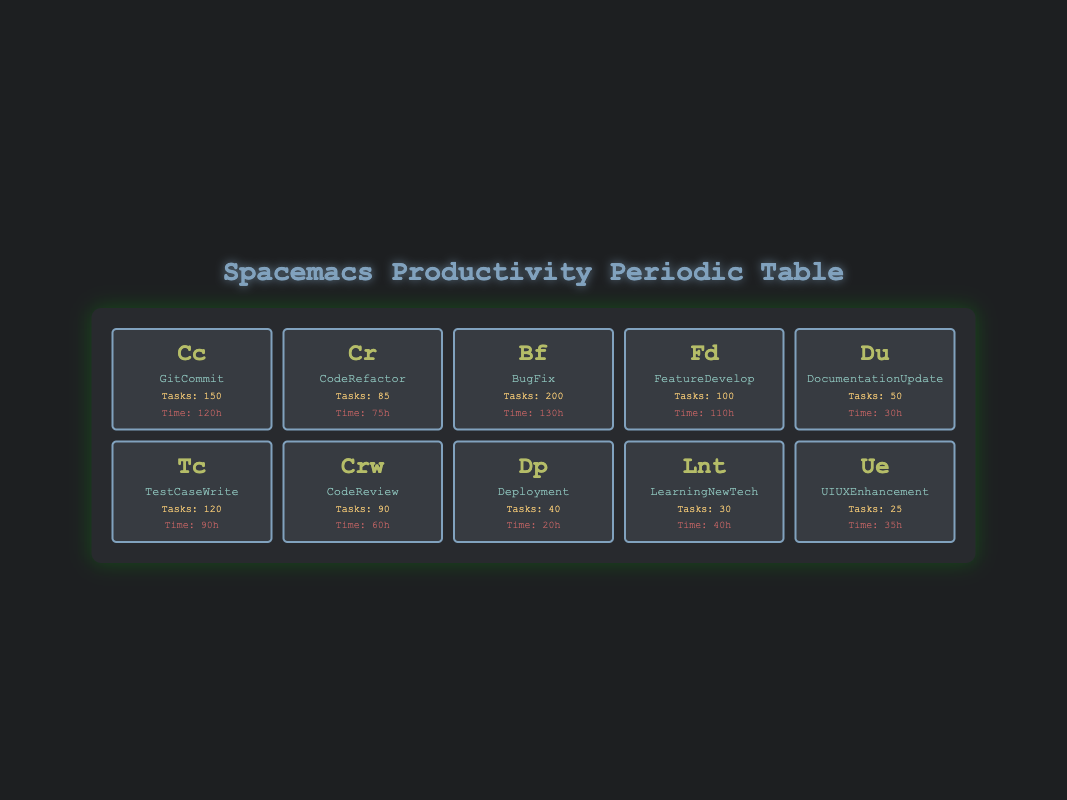What is the total number of tasks completed across all categories? To find the total number of tasks, we add the tasks completed for all categories: 150 (GitCommit) + 85 (CodeRefactor) + 200 (BugFix) + 100 (FeatureDevelop) + 50 (DocumentationUpdate) + 120 (TestCaseWrite) + 90 (CodeReview) + 40 (Deployment) + 30 (LearningNewTech) + 25 (UIUXEnhancement) = 1,050.
Answer: 1050 Which category has the highest time spent? The time spent for each category is: 120 (GitCommit), 75 (CodeRefactor), 130 (BugFix), 110 (FeatureDevelop), 30 (DocumentationUpdate), 90 (TestCaseWrite), 60 (CodeReview), 20 (Deployment), 40 (LearningNewTech), and 35 (UIUXEnhancement). The maximum time spent is 130 in the BugFix category.
Answer: BugFix Is the number of tasks completed for Deployment greater than the number of tasks for LearningNewTech? The tasks completed for Deployment is 40, and for LearningNewTech it is 30. Since 40 is greater than 30, the statement is true.
Answer: Yes What is the average time spent on tasks for the top 3 categories by tasks completed? The top 3 categories by tasks completed are: BugFix (200), GitCommit (150), and TestCaseWrite (120). Their corresponding time spent is 130 (BugFix), 120 (GitCommit), and 90 (TestCaseWrite). The average time is calculated as (130 + 120 + 90) / 3 = 340 / 3 = approximately 113.33 hours.
Answer: 113.33 How many more tasks were completed in BugFix compared to DocumentationUpdate? The tasks completed in BugFix is 200 and in DocumentationUpdate is 50. The difference is 200 - 50 = 150 tasks.
Answer: 150 Which element has the least number of tasks completed? The tasks completed for elements are: 150 (GitCommit), 85 (CodeRefactor), 200 (BugFix), 100 (FeatureDevelop), 50 (DocumentationUpdate), 120 (TestCaseWrite), 90 (CodeReview), 40 (Deployment), 30 (LearningNewTech), and 25 (UIUXEnhancement). The least is 25 from UIUXEnhancement.
Answer: UIUXEnhancement What percentage of the total tasks does CodeReview represent? The total tasks completed is 1,050, and CodeReview completed 90 tasks. The percentage is calculated as (90 / 1050) * 100 = approximately 8.57%.
Answer: 8.57% Is the total time spent on CodeRefactor and FeatureDevelop less than that on BugFix? The time spent on CodeRefactor is 75 and on FeatureDevelop is 110, summing these gives 75 + 110 = 185. The time spent on BugFix is 130. Since 185 is greater than 130, the statement is false.
Answer: No 